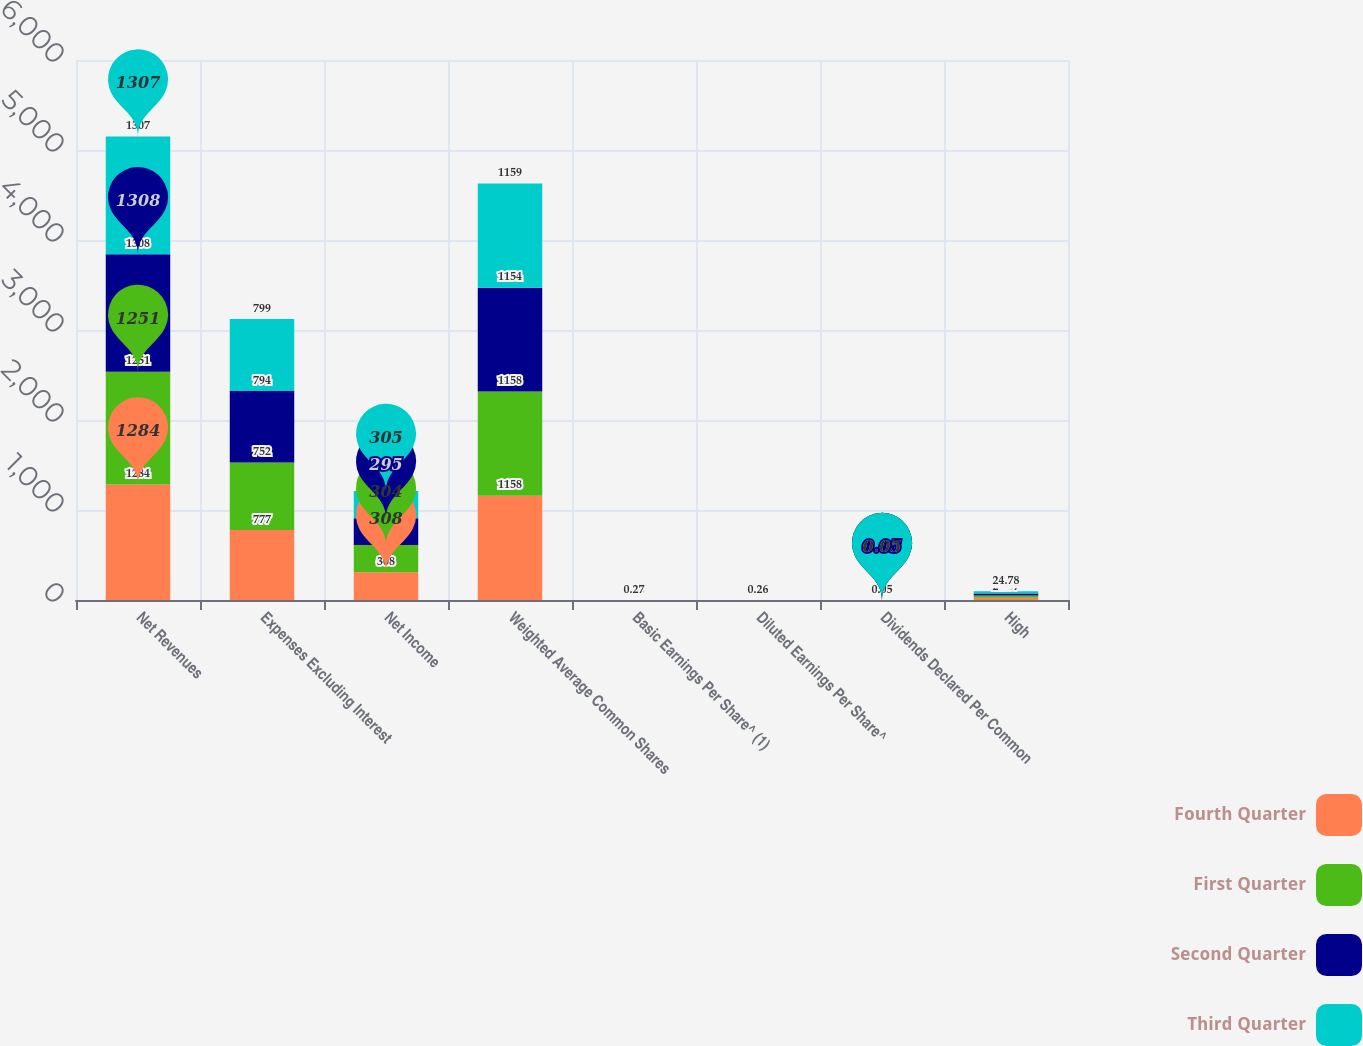<chart> <loc_0><loc_0><loc_500><loc_500><stacked_bar_chart><ecel><fcel>Net Revenues<fcel>Expenses Excluding Interest<fcel>Net Income<fcel>Weighted Average Common Shares<fcel>Basic Earnings Per Share^ (1)<fcel>Diluted Earnings Per Share^<fcel>Dividends Declared Per Common<fcel>High<nl><fcel>Fourth Quarter<fcel>1284<fcel>777<fcel>308<fcel>1158<fcel>0.27<fcel>0.27<fcel>0.06<fcel>24.37<nl><fcel>First Quarter<fcel>1251<fcel>752<fcel>304<fcel>1158<fcel>0.26<fcel>0.26<fcel>0.06<fcel>26<nl><fcel>Second Quarter<fcel>1308<fcel>794<fcel>295<fcel>1154<fcel>0.26<fcel>0.26<fcel>0.05<fcel>22.78<nl><fcel>Third Quarter<fcel>1307<fcel>799<fcel>305<fcel>1159<fcel>0.27<fcel>0.26<fcel>0.05<fcel>24.78<nl></chart> 